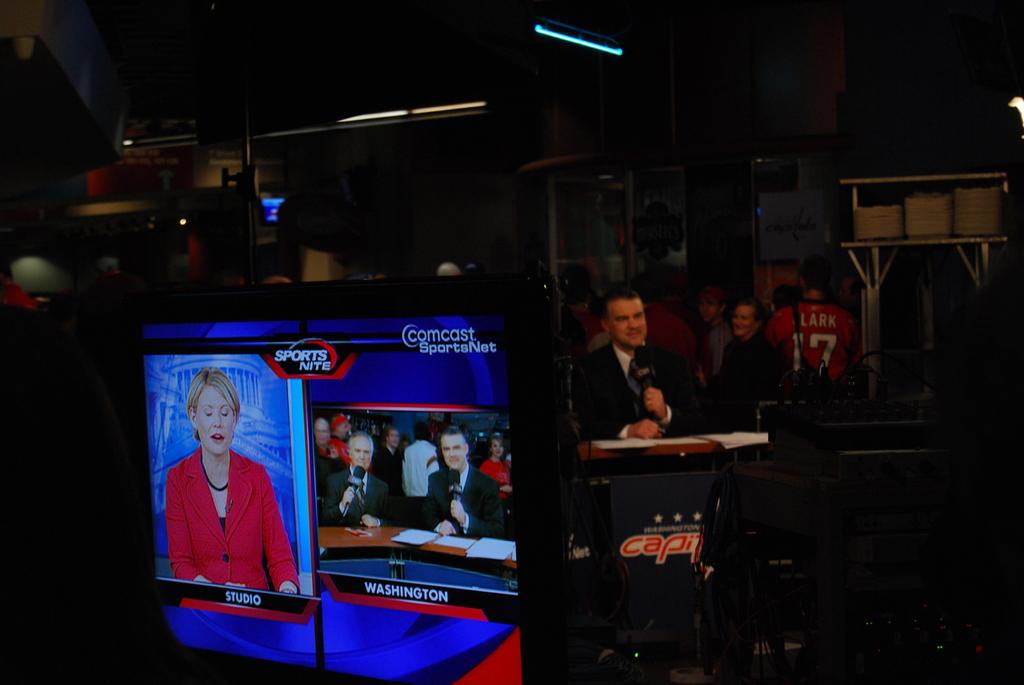What is the main object in the image? There is a screen in the image. Who or what can be seen in the image? There are people in the image. What is the man holding in his hand? The man is holding a microphone in his hand. Where is the man standing in the image? The man is standing at a podium. What can be seen in the background of the image? There are lights visible in the background, and the background appears to be dark. What type of button can be seen in the alley in the image? There is no button or alley present in the image. What impulse might the people in the image be experiencing? We cannot determine the impulses of the people in the image based on the provided facts. 